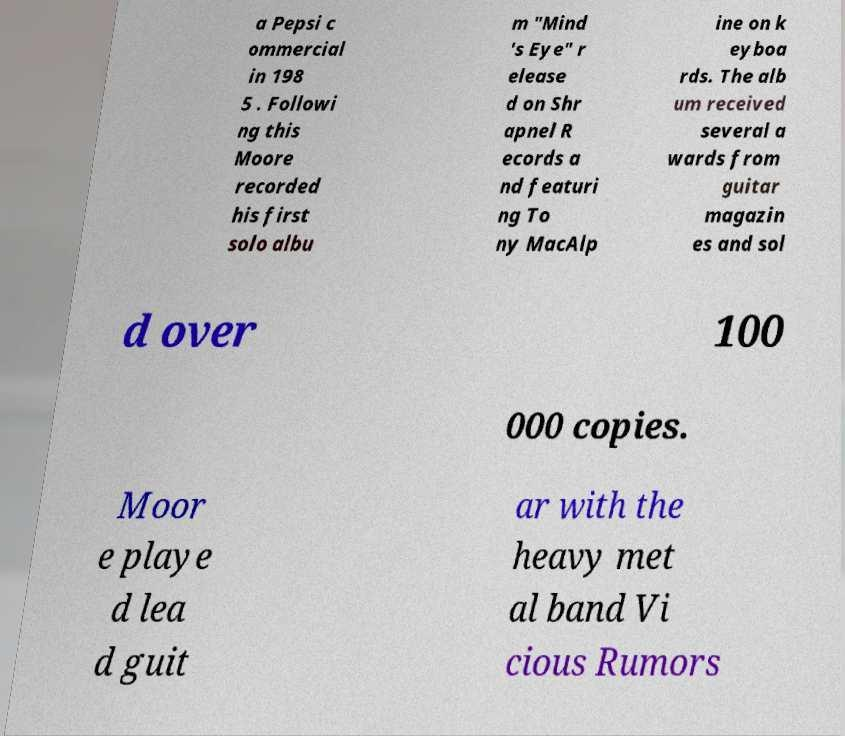Can you read and provide the text displayed in the image?This photo seems to have some interesting text. Can you extract and type it out for me? a Pepsi c ommercial in 198 5 . Followi ng this Moore recorded his first solo albu m "Mind 's Eye" r elease d on Shr apnel R ecords a nd featuri ng To ny MacAlp ine on k eyboa rds. The alb um received several a wards from guitar magazin es and sol d over 100 000 copies. Moor e playe d lea d guit ar with the heavy met al band Vi cious Rumors 